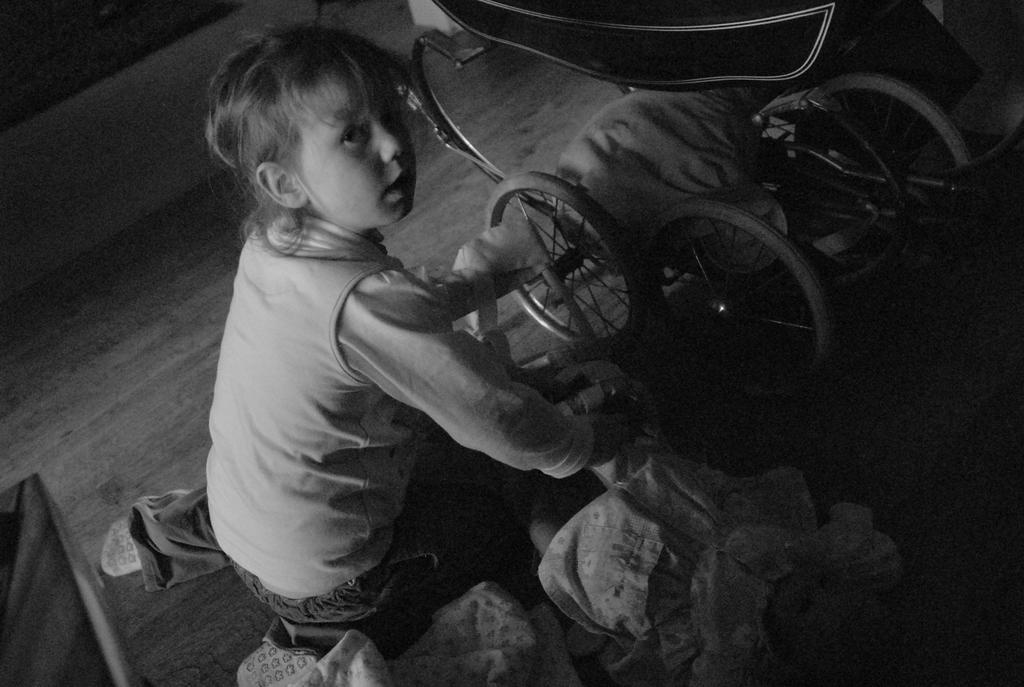In one or two sentences, can you explain what this image depicts? This is a black and white image. There is a girl in the center of the image. There is a wheelchair. At the bottom of the image there is a wooden flooring. 